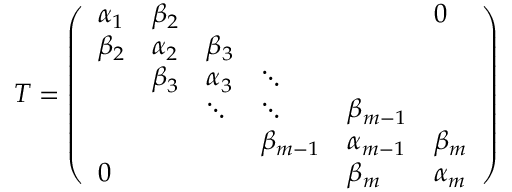Convert formula to latex. <formula><loc_0><loc_0><loc_500><loc_500>T = { \left ( \begin{array} { l l l l l l } { \alpha _ { 1 } } & { \beta _ { 2 } } & & & & { 0 } \\ { \beta _ { 2 } } & { \alpha _ { 2 } } & { \beta _ { 3 } } & & & \\ & { \beta _ { 3 } } & { \alpha _ { 3 } } & { \ddots } & & \\ & & { \ddots } & { \ddots } & { \beta _ { m - 1 } } & \\ & & & { \beta _ { m - 1 } } & { \alpha _ { m - 1 } } & { \beta _ { m } } \\ { 0 } & & & & { \beta _ { m } } & { \alpha _ { m } } \end{array} \right ) }</formula> 